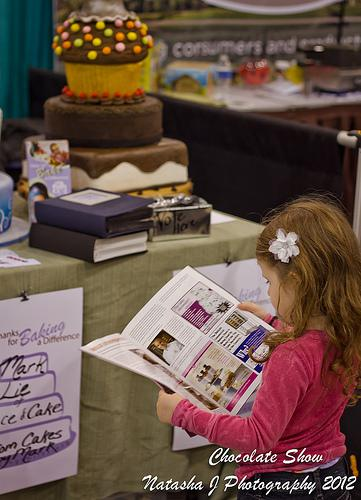Question: what is the girl holding?
Choices:
A. A magazine.
B. A hairbrush.
C. A toothpick.
D. A screwdriver.
Answer with the letter. Answer: A Question: when was this picture taken?
Choices:
A. Midnight.
B. Morning.
C. 2012.
D. 2:00pm.
Answer with the letter. Answer: C Question: what is in the girl's hair?
Choices:
A. A barrette.
B. A headband.
C. A flower.
D. A ribbon.
Answer with the letter. Answer: C Question: who is holding the magazine in the picture?
Choices:
A. A dog.
B. A girl.
C. A baby.
D. A woman.
Answer with the letter. Answer: B Question: who took this picture?
Choices:
A. A woman.
B. A girl.
C. Natasha J Photography.
D. A professional.
Answer with the letter. Answer: C Question: where was this picture taken at?
Choices:
A. Chocolate show.
B. Circus.
C. Cooking show.
D. College.
Answer with the letter. Answer: A 